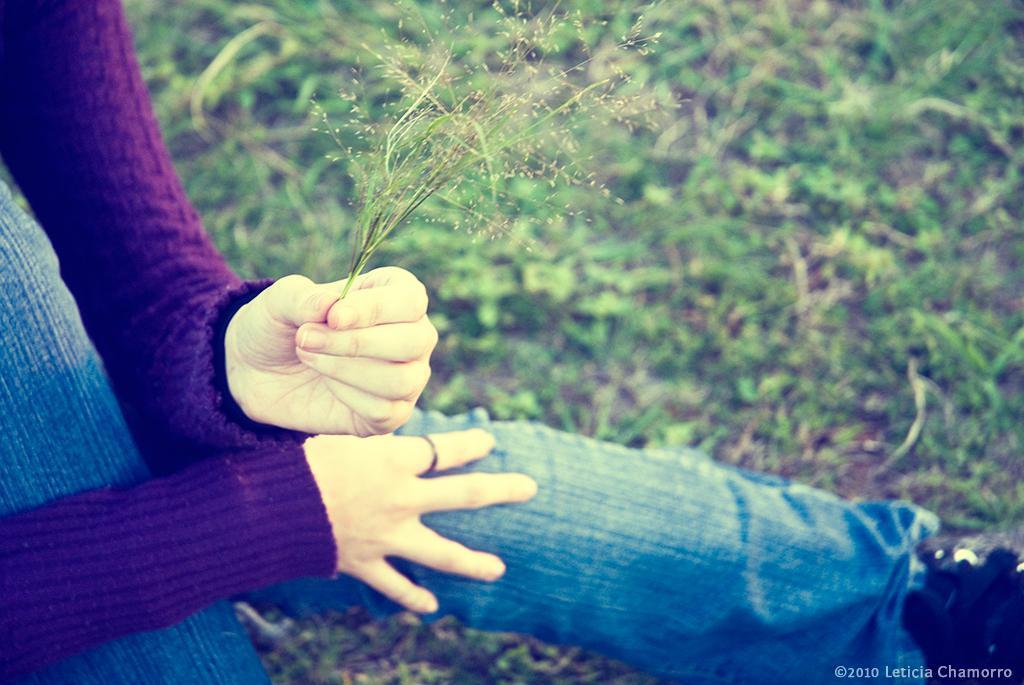Describe this image in one or two sentences. In this image there is a person holding grass, in the background there is a grassland, on the bottom right there is text. 